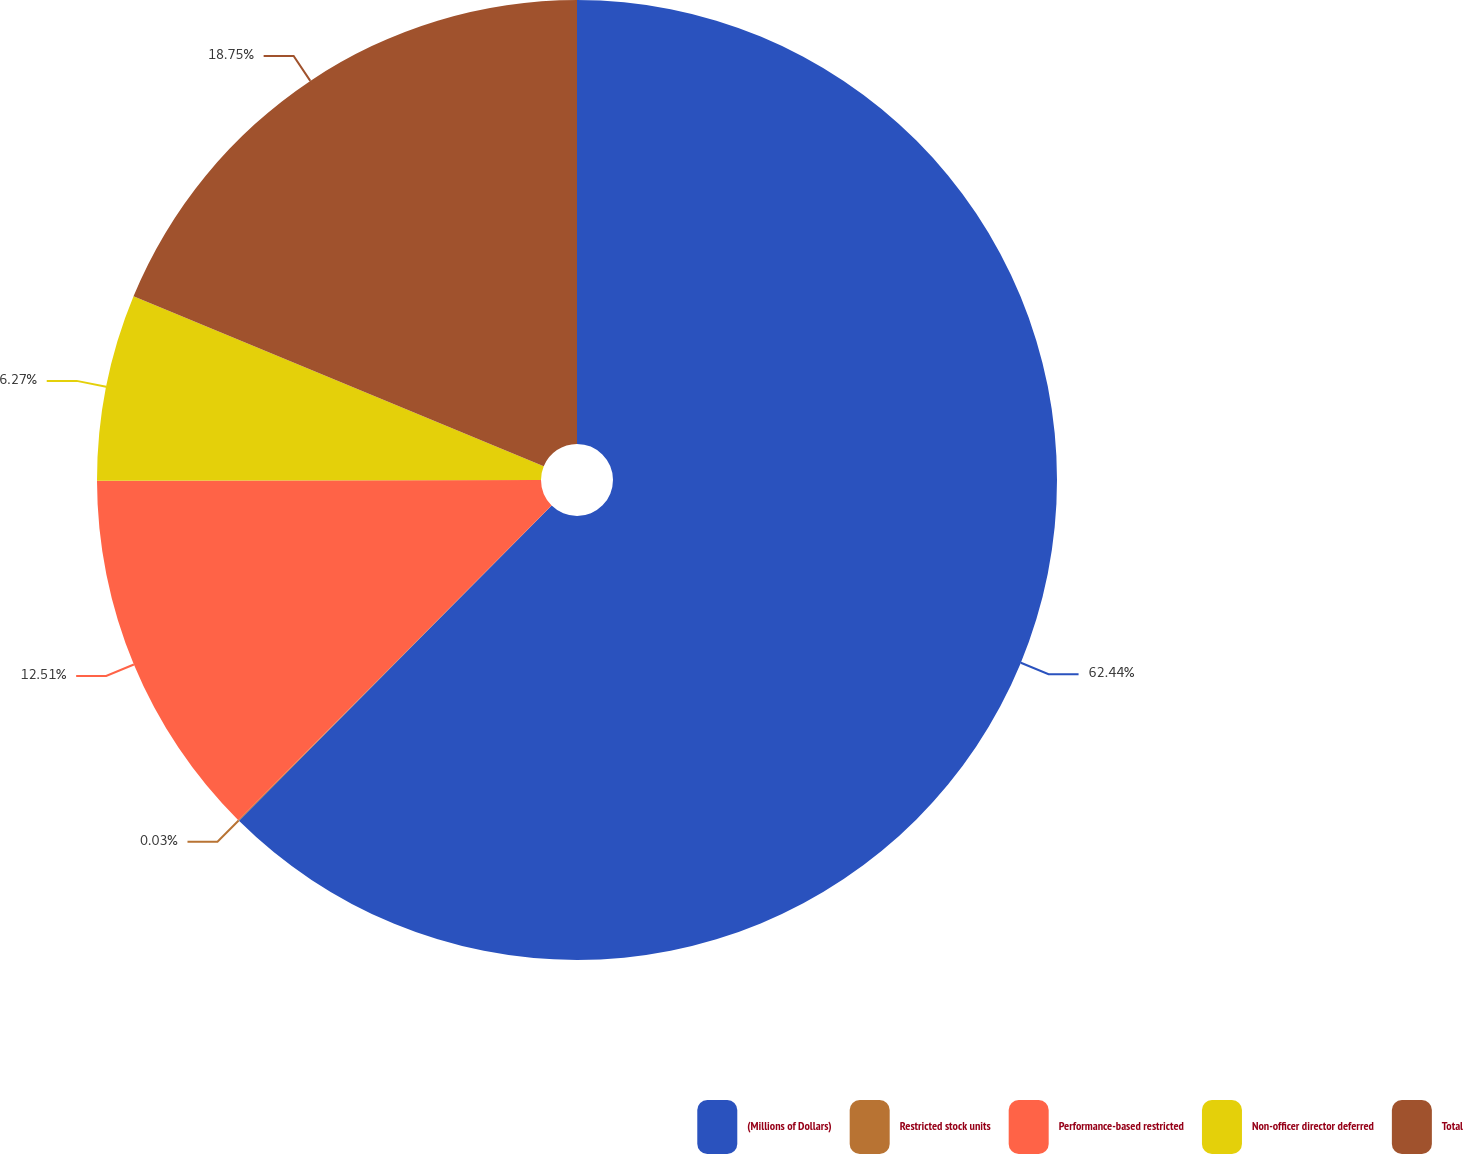Convert chart to OTSL. <chart><loc_0><loc_0><loc_500><loc_500><pie_chart><fcel>(Millions of Dollars)<fcel>Restricted stock units<fcel>Performance-based restricted<fcel>Non-officer director deferred<fcel>Total<nl><fcel>62.43%<fcel>0.03%<fcel>12.51%<fcel>6.27%<fcel>18.75%<nl></chart> 